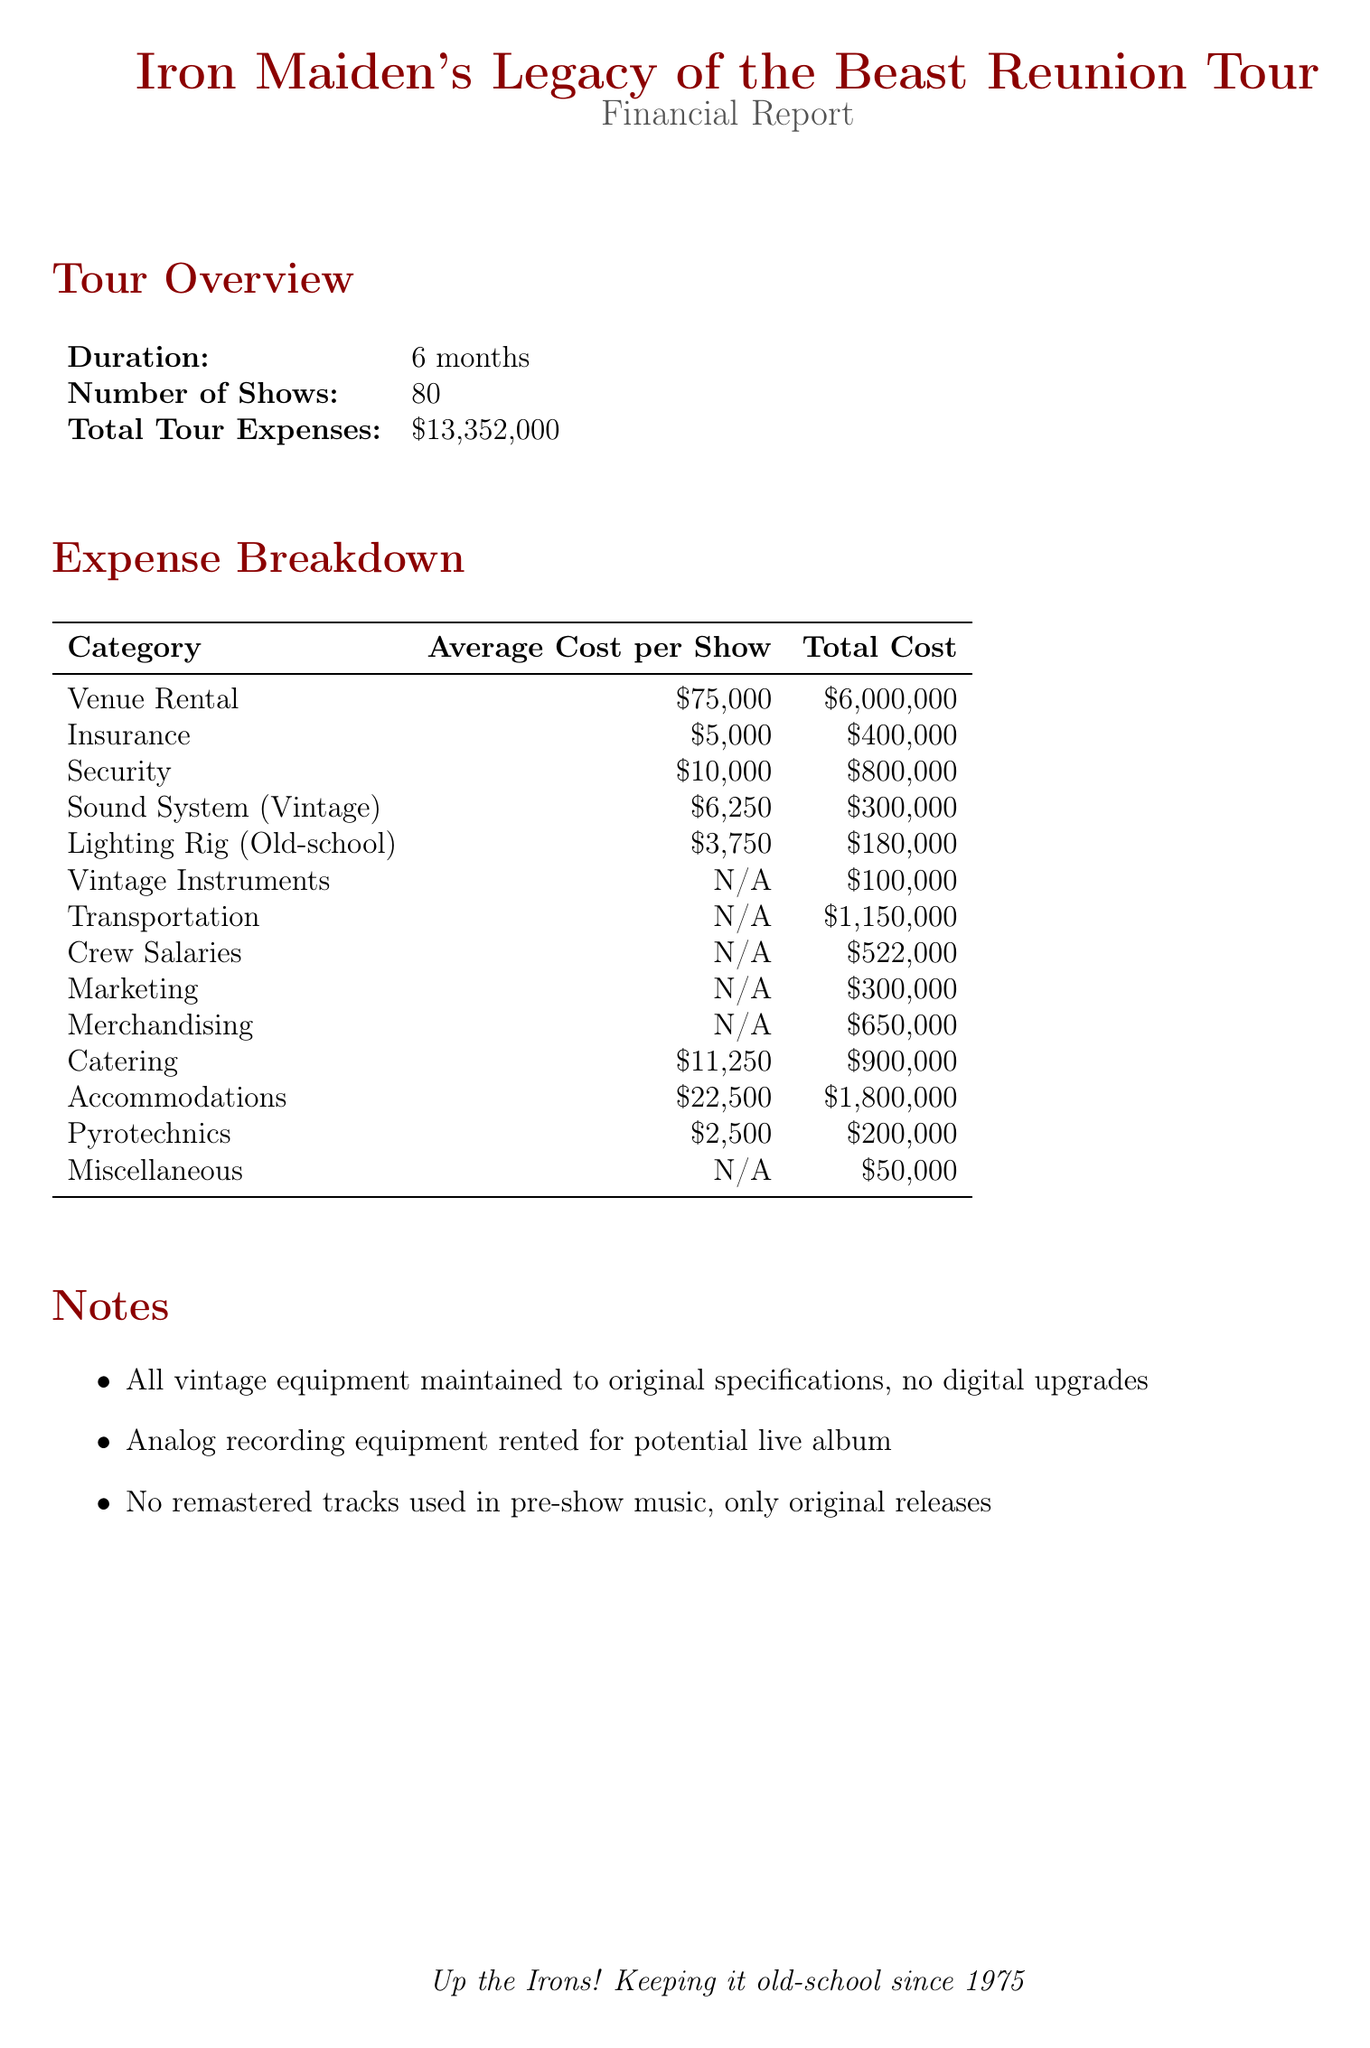What is the tour name? The tour name is explicitly mentioned in the document as "Iron Maiden's Legacy of the Beast Reunion Tour."
Answer: Iron Maiden's Legacy of the Beast Reunion Tour What is the total cost for venue rental? Venue rental is detailed in the expense breakdown, totaling $6,000,000.
Answer: $6,000,000 How many shows are included in the tour? The number of shows is specified in the tour overview section as 80.
Answer: 80 What is the total cost of merchandise? The merchandising section lists the total cost as $650,000.
Answer: $650,000 What type of security expense is included? The type of security expense is labeled as "Security" in the venue costs.
Answer: Security What is one of the marketing expenses? The marketing section mentions several types; one example is "Print ads in Metal Hammer and Kerrang!"
Answer: Print ads in Metal Hammer and Kerrang! How much does it cost for vintage instruments? The one-time cost for vintage instruments is stated as $100,000.
Answer: $100,000 What type of pyrotechnics is used? The document specifies the type of pyrotechnics as "old-school fire effects."
Answer: old-school fire effects How many tour buses are being rented? The transportation section states that 3 tour buses are rented.
Answer: 3 What is the main note regarding equipment? A key note states that "All vintage equipment maintained to original specifications, no digital upgrades."
Answer: All vintage equipment maintained to original specifications, no digital upgrades 